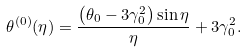<formula> <loc_0><loc_0><loc_500><loc_500>\theta ^ { ( 0 ) } ( \eta ) = \frac { \left ( \theta _ { 0 } - 3 \gamma _ { 0 } ^ { 2 } \right ) \sin \eta } { \eta } + 3 \gamma _ { 0 } ^ { 2 } .</formula> 